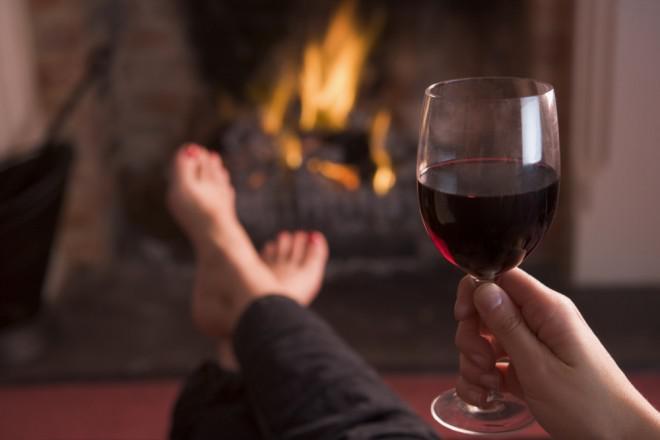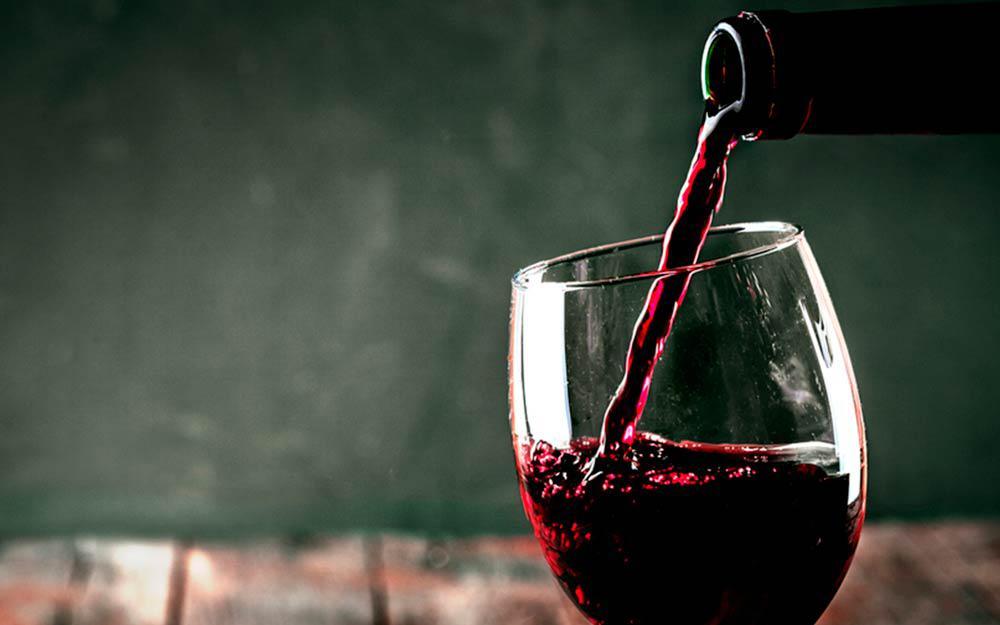The first image is the image on the left, the second image is the image on the right. For the images displayed, is the sentence "Wine is shown flowing from the bottle into the glass in exactly one image, and both images include a glass of wine and at least one bottle." factually correct? Answer yes or no. No. The first image is the image on the left, the second image is the image on the right. Considering the images on both sides, is "One of the images shows red wine being poured by a bottle placed at the left of the wine glass." valid? Answer yes or no. No. 